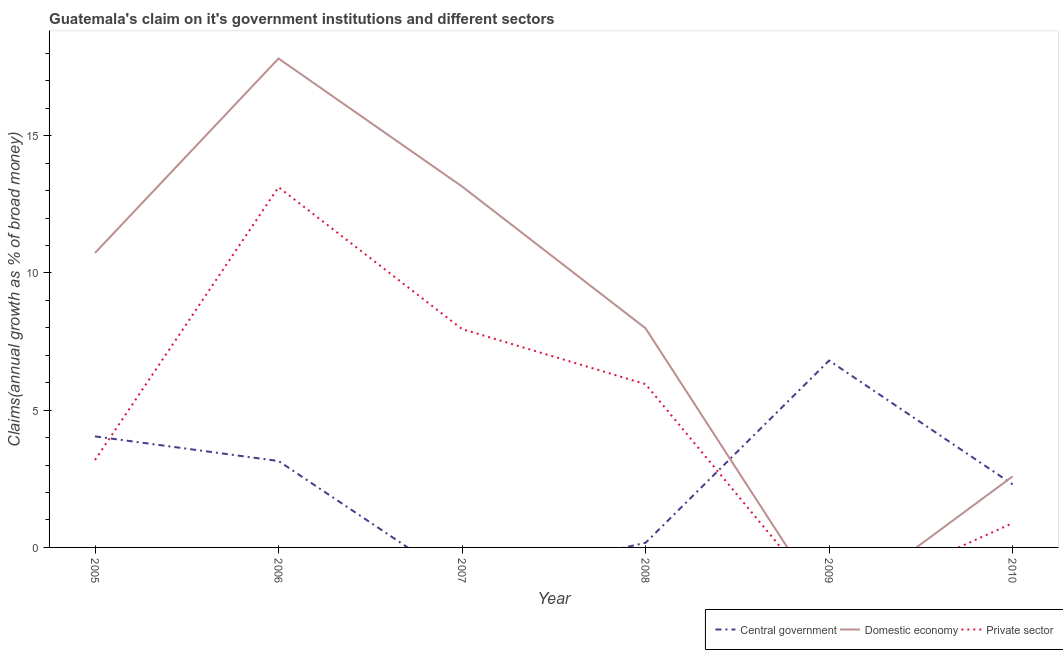How many different coloured lines are there?
Offer a very short reply. 3. Does the line corresponding to percentage of claim on the private sector intersect with the line corresponding to percentage of claim on the domestic economy?
Your response must be concise. Yes. Is the number of lines equal to the number of legend labels?
Your response must be concise. No. What is the percentage of claim on the central government in 2005?
Your response must be concise. 4.05. Across all years, what is the maximum percentage of claim on the domestic economy?
Make the answer very short. 17.81. Across all years, what is the minimum percentage of claim on the domestic economy?
Your response must be concise. 0. In which year was the percentage of claim on the private sector maximum?
Provide a succinct answer. 2006. What is the total percentage of claim on the central government in the graph?
Offer a terse response. 16.47. What is the difference between the percentage of claim on the private sector in 2005 and that in 2007?
Your answer should be very brief. -4.77. What is the difference between the percentage of claim on the central government in 2008 and the percentage of claim on the private sector in 2009?
Your response must be concise. 0.17. What is the average percentage of claim on the central government per year?
Give a very brief answer. 2.75. In the year 2010, what is the difference between the percentage of claim on the private sector and percentage of claim on the central government?
Your response must be concise. -1.41. What is the ratio of the percentage of claim on the private sector in 2005 to that in 2010?
Keep it short and to the point. 3.6. Is the percentage of claim on the private sector in 2005 less than that in 2008?
Make the answer very short. Yes. What is the difference between the highest and the second highest percentage of claim on the central government?
Offer a terse response. 2.76. What is the difference between the highest and the lowest percentage of claim on the central government?
Your response must be concise. 6.81. In how many years, is the percentage of claim on the domestic economy greater than the average percentage of claim on the domestic economy taken over all years?
Ensure brevity in your answer.  3. Does the percentage of claim on the domestic economy monotonically increase over the years?
Make the answer very short. No. Is the percentage of claim on the private sector strictly less than the percentage of claim on the central government over the years?
Make the answer very short. No. What is the difference between two consecutive major ticks on the Y-axis?
Offer a very short reply. 5. Does the graph contain any zero values?
Your answer should be compact. Yes. How many legend labels are there?
Your response must be concise. 3. What is the title of the graph?
Your answer should be very brief. Guatemala's claim on it's government institutions and different sectors. What is the label or title of the Y-axis?
Keep it short and to the point. Claims(annual growth as % of broad money). What is the Claims(annual growth as % of broad money) in Central government in 2005?
Provide a succinct answer. 4.05. What is the Claims(annual growth as % of broad money) in Domestic economy in 2005?
Give a very brief answer. 10.73. What is the Claims(annual growth as % of broad money) in Private sector in 2005?
Your answer should be compact. 3.19. What is the Claims(annual growth as % of broad money) of Central government in 2006?
Give a very brief answer. 3.15. What is the Claims(annual growth as % of broad money) of Domestic economy in 2006?
Provide a succinct answer. 17.81. What is the Claims(annual growth as % of broad money) of Private sector in 2006?
Provide a succinct answer. 13.13. What is the Claims(annual growth as % of broad money) in Domestic economy in 2007?
Provide a short and direct response. 13.15. What is the Claims(annual growth as % of broad money) of Private sector in 2007?
Give a very brief answer. 7.96. What is the Claims(annual growth as % of broad money) of Central government in 2008?
Your answer should be compact. 0.17. What is the Claims(annual growth as % of broad money) in Domestic economy in 2008?
Offer a terse response. 7.98. What is the Claims(annual growth as % of broad money) in Private sector in 2008?
Provide a short and direct response. 5.95. What is the Claims(annual growth as % of broad money) in Central government in 2009?
Give a very brief answer. 6.81. What is the Claims(annual growth as % of broad money) in Private sector in 2009?
Offer a very short reply. 0. What is the Claims(annual growth as % of broad money) in Central government in 2010?
Provide a short and direct response. 2.3. What is the Claims(annual growth as % of broad money) in Domestic economy in 2010?
Your answer should be compact. 2.59. What is the Claims(annual growth as % of broad money) of Private sector in 2010?
Offer a very short reply. 0.88. Across all years, what is the maximum Claims(annual growth as % of broad money) in Central government?
Your answer should be compact. 6.81. Across all years, what is the maximum Claims(annual growth as % of broad money) in Domestic economy?
Make the answer very short. 17.81. Across all years, what is the maximum Claims(annual growth as % of broad money) in Private sector?
Offer a terse response. 13.13. Across all years, what is the minimum Claims(annual growth as % of broad money) in Domestic economy?
Your answer should be compact. 0. Across all years, what is the minimum Claims(annual growth as % of broad money) in Private sector?
Your answer should be very brief. 0. What is the total Claims(annual growth as % of broad money) in Central government in the graph?
Give a very brief answer. 16.47. What is the total Claims(annual growth as % of broad money) of Domestic economy in the graph?
Provide a succinct answer. 52.27. What is the total Claims(annual growth as % of broad money) in Private sector in the graph?
Offer a terse response. 31.1. What is the difference between the Claims(annual growth as % of broad money) in Central government in 2005 and that in 2006?
Your answer should be very brief. 0.9. What is the difference between the Claims(annual growth as % of broad money) of Domestic economy in 2005 and that in 2006?
Keep it short and to the point. -7.08. What is the difference between the Claims(annual growth as % of broad money) in Private sector in 2005 and that in 2006?
Your answer should be very brief. -9.94. What is the difference between the Claims(annual growth as % of broad money) in Domestic economy in 2005 and that in 2007?
Your answer should be very brief. -2.42. What is the difference between the Claims(annual growth as % of broad money) in Private sector in 2005 and that in 2007?
Your response must be concise. -4.77. What is the difference between the Claims(annual growth as % of broad money) in Central government in 2005 and that in 2008?
Make the answer very short. 3.88. What is the difference between the Claims(annual growth as % of broad money) of Domestic economy in 2005 and that in 2008?
Your response must be concise. 2.75. What is the difference between the Claims(annual growth as % of broad money) of Private sector in 2005 and that in 2008?
Give a very brief answer. -2.76. What is the difference between the Claims(annual growth as % of broad money) in Central government in 2005 and that in 2009?
Make the answer very short. -2.76. What is the difference between the Claims(annual growth as % of broad money) of Central government in 2005 and that in 2010?
Your answer should be compact. 1.75. What is the difference between the Claims(annual growth as % of broad money) of Domestic economy in 2005 and that in 2010?
Make the answer very short. 8.14. What is the difference between the Claims(annual growth as % of broad money) in Private sector in 2005 and that in 2010?
Your answer should be very brief. 2.3. What is the difference between the Claims(annual growth as % of broad money) of Domestic economy in 2006 and that in 2007?
Your answer should be compact. 4.66. What is the difference between the Claims(annual growth as % of broad money) in Private sector in 2006 and that in 2007?
Provide a succinct answer. 5.17. What is the difference between the Claims(annual growth as % of broad money) in Central government in 2006 and that in 2008?
Provide a short and direct response. 2.98. What is the difference between the Claims(annual growth as % of broad money) in Domestic economy in 2006 and that in 2008?
Give a very brief answer. 9.83. What is the difference between the Claims(annual growth as % of broad money) of Private sector in 2006 and that in 2008?
Offer a terse response. 7.18. What is the difference between the Claims(annual growth as % of broad money) of Central government in 2006 and that in 2009?
Keep it short and to the point. -3.66. What is the difference between the Claims(annual growth as % of broad money) of Central government in 2006 and that in 2010?
Ensure brevity in your answer.  0.85. What is the difference between the Claims(annual growth as % of broad money) in Domestic economy in 2006 and that in 2010?
Your response must be concise. 15.23. What is the difference between the Claims(annual growth as % of broad money) of Private sector in 2006 and that in 2010?
Provide a succinct answer. 12.24. What is the difference between the Claims(annual growth as % of broad money) in Domestic economy in 2007 and that in 2008?
Keep it short and to the point. 5.17. What is the difference between the Claims(annual growth as % of broad money) of Private sector in 2007 and that in 2008?
Make the answer very short. 2.01. What is the difference between the Claims(annual growth as % of broad money) in Domestic economy in 2007 and that in 2010?
Ensure brevity in your answer.  10.56. What is the difference between the Claims(annual growth as % of broad money) in Private sector in 2007 and that in 2010?
Offer a terse response. 7.07. What is the difference between the Claims(annual growth as % of broad money) in Central government in 2008 and that in 2009?
Your answer should be very brief. -6.64. What is the difference between the Claims(annual growth as % of broad money) of Central government in 2008 and that in 2010?
Offer a very short reply. -2.13. What is the difference between the Claims(annual growth as % of broad money) of Domestic economy in 2008 and that in 2010?
Offer a terse response. 5.39. What is the difference between the Claims(annual growth as % of broad money) of Private sector in 2008 and that in 2010?
Ensure brevity in your answer.  5.06. What is the difference between the Claims(annual growth as % of broad money) of Central government in 2009 and that in 2010?
Make the answer very short. 4.51. What is the difference between the Claims(annual growth as % of broad money) in Central government in 2005 and the Claims(annual growth as % of broad money) in Domestic economy in 2006?
Ensure brevity in your answer.  -13.77. What is the difference between the Claims(annual growth as % of broad money) of Central government in 2005 and the Claims(annual growth as % of broad money) of Private sector in 2006?
Keep it short and to the point. -9.08. What is the difference between the Claims(annual growth as % of broad money) in Domestic economy in 2005 and the Claims(annual growth as % of broad money) in Private sector in 2006?
Offer a very short reply. -2.4. What is the difference between the Claims(annual growth as % of broad money) of Central government in 2005 and the Claims(annual growth as % of broad money) of Domestic economy in 2007?
Provide a succinct answer. -9.11. What is the difference between the Claims(annual growth as % of broad money) of Central government in 2005 and the Claims(annual growth as % of broad money) of Private sector in 2007?
Offer a terse response. -3.91. What is the difference between the Claims(annual growth as % of broad money) in Domestic economy in 2005 and the Claims(annual growth as % of broad money) in Private sector in 2007?
Give a very brief answer. 2.77. What is the difference between the Claims(annual growth as % of broad money) of Central government in 2005 and the Claims(annual growth as % of broad money) of Domestic economy in 2008?
Your answer should be compact. -3.94. What is the difference between the Claims(annual growth as % of broad money) in Central government in 2005 and the Claims(annual growth as % of broad money) in Private sector in 2008?
Ensure brevity in your answer.  -1.9. What is the difference between the Claims(annual growth as % of broad money) in Domestic economy in 2005 and the Claims(annual growth as % of broad money) in Private sector in 2008?
Make the answer very short. 4.78. What is the difference between the Claims(annual growth as % of broad money) in Central government in 2005 and the Claims(annual growth as % of broad money) in Domestic economy in 2010?
Offer a terse response. 1.46. What is the difference between the Claims(annual growth as % of broad money) in Central government in 2005 and the Claims(annual growth as % of broad money) in Private sector in 2010?
Give a very brief answer. 3.16. What is the difference between the Claims(annual growth as % of broad money) in Domestic economy in 2005 and the Claims(annual growth as % of broad money) in Private sector in 2010?
Your answer should be compact. 9.84. What is the difference between the Claims(annual growth as % of broad money) of Central government in 2006 and the Claims(annual growth as % of broad money) of Domestic economy in 2007?
Make the answer very short. -10. What is the difference between the Claims(annual growth as % of broad money) in Central government in 2006 and the Claims(annual growth as % of broad money) in Private sector in 2007?
Your answer should be very brief. -4.81. What is the difference between the Claims(annual growth as % of broad money) in Domestic economy in 2006 and the Claims(annual growth as % of broad money) in Private sector in 2007?
Offer a very short reply. 9.86. What is the difference between the Claims(annual growth as % of broad money) of Central government in 2006 and the Claims(annual growth as % of broad money) of Domestic economy in 2008?
Make the answer very short. -4.83. What is the difference between the Claims(annual growth as % of broad money) of Central government in 2006 and the Claims(annual growth as % of broad money) of Private sector in 2008?
Provide a short and direct response. -2.8. What is the difference between the Claims(annual growth as % of broad money) in Domestic economy in 2006 and the Claims(annual growth as % of broad money) in Private sector in 2008?
Provide a succinct answer. 11.87. What is the difference between the Claims(annual growth as % of broad money) in Central government in 2006 and the Claims(annual growth as % of broad money) in Domestic economy in 2010?
Your answer should be very brief. 0.56. What is the difference between the Claims(annual growth as % of broad money) in Central government in 2006 and the Claims(annual growth as % of broad money) in Private sector in 2010?
Provide a short and direct response. 2.26. What is the difference between the Claims(annual growth as % of broad money) in Domestic economy in 2006 and the Claims(annual growth as % of broad money) in Private sector in 2010?
Your answer should be compact. 16.93. What is the difference between the Claims(annual growth as % of broad money) in Domestic economy in 2007 and the Claims(annual growth as % of broad money) in Private sector in 2008?
Make the answer very short. 7.2. What is the difference between the Claims(annual growth as % of broad money) of Domestic economy in 2007 and the Claims(annual growth as % of broad money) of Private sector in 2010?
Offer a terse response. 12.27. What is the difference between the Claims(annual growth as % of broad money) in Central government in 2008 and the Claims(annual growth as % of broad money) in Domestic economy in 2010?
Offer a very short reply. -2.42. What is the difference between the Claims(annual growth as % of broad money) in Central government in 2008 and the Claims(annual growth as % of broad money) in Private sector in 2010?
Give a very brief answer. -0.72. What is the difference between the Claims(annual growth as % of broad money) in Domestic economy in 2008 and the Claims(annual growth as % of broad money) in Private sector in 2010?
Provide a short and direct response. 7.1. What is the difference between the Claims(annual growth as % of broad money) of Central government in 2009 and the Claims(annual growth as % of broad money) of Domestic economy in 2010?
Your answer should be very brief. 4.22. What is the difference between the Claims(annual growth as % of broad money) in Central government in 2009 and the Claims(annual growth as % of broad money) in Private sector in 2010?
Make the answer very short. 5.92. What is the average Claims(annual growth as % of broad money) in Central government per year?
Your answer should be compact. 2.75. What is the average Claims(annual growth as % of broad money) of Domestic economy per year?
Your answer should be very brief. 8.71. What is the average Claims(annual growth as % of broad money) of Private sector per year?
Provide a short and direct response. 5.18. In the year 2005, what is the difference between the Claims(annual growth as % of broad money) of Central government and Claims(annual growth as % of broad money) of Domestic economy?
Ensure brevity in your answer.  -6.68. In the year 2005, what is the difference between the Claims(annual growth as % of broad money) in Central government and Claims(annual growth as % of broad money) in Private sector?
Give a very brief answer. 0.86. In the year 2005, what is the difference between the Claims(annual growth as % of broad money) in Domestic economy and Claims(annual growth as % of broad money) in Private sector?
Offer a terse response. 7.54. In the year 2006, what is the difference between the Claims(annual growth as % of broad money) of Central government and Claims(annual growth as % of broad money) of Domestic economy?
Keep it short and to the point. -14.67. In the year 2006, what is the difference between the Claims(annual growth as % of broad money) in Central government and Claims(annual growth as % of broad money) in Private sector?
Provide a succinct answer. -9.98. In the year 2006, what is the difference between the Claims(annual growth as % of broad money) of Domestic economy and Claims(annual growth as % of broad money) of Private sector?
Offer a very short reply. 4.69. In the year 2007, what is the difference between the Claims(annual growth as % of broad money) of Domestic economy and Claims(annual growth as % of broad money) of Private sector?
Ensure brevity in your answer.  5.2. In the year 2008, what is the difference between the Claims(annual growth as % of broad money) in Central government and Claims(annual growth as % of broad money) in Domestic economy?
Offer a terse response. -7.81. In the year 2008, what is the difference between the Claims(annual growth as % of broad money) of Central government and Claims(annual growth as % of broad money) of Private sector?
Provide a short and direct response. -5.78. In the year 2008, what is the difference between the Claims(annual growth as % of broad money) of Domestic economy and Claims(annual growth as % of broad money) of Private sector?
Provide a succinct answer. 2.03. In the year 2010, what is the difference between the Claims(annual growth as % of broad money) in Central government and Claims(annual growth as % of broad money) in Domestic economy?
Your answer should be very brief. -0.29. In the year 2010, what is the difference between the Claims(annual growth as % of broad money) of Central government and Claims(annual growth as % of broad money) of Private sector?
Offer a very short reply. 1.41. In the year 2010, what is the difference between the Claims(annual growth as % of broad money) in Domestic economy and Claims(annual growth as % of broad money) in Private sector?
Your answer should be very brief. 1.7. What is the ratio of the Claims(annual growth as % of broad money) in Central government in 2005 to that in 2006?
Provide a short and direct response. 1.28. What is the ratio of the Claims(annual growth as % of broad money) in Domestic economy in 2005 to that in 2006?
Give a very brief answer. 0.6. What is the ratio of the Claims(annual growth as % of broad money) of Private sector in 2005 to that in 2006?
Keep it short and to the point. 0.24. What is the ratio of the Claims(annual growth as % of broad money) of Domestic economy in 2005 to that in 2007?
Your answer should be very brief. 0.82. What is the ratio of the Claims(annual growth as % of broad money) of Private sector in 2005 to that in 2007?
Your response must be concise. 0.4. What is the ratio of the Claims(annual growth as % of broad money) in Central government in 2005 to that in 2008?
Provide a succinct answer. 23.95. What is the ratio of the Claims(annual growth as % of broad money) in Domestic economy in 2005 to that in 2008?
Give a very brief answer. 1.34. What is the ratio of the Claims(annual growth as % of broad money) of Private sector in 2005 to that in 2008?
Offer a terse response. 0.54. What is the ratio of the Claims(annual growth as % of broad money) of Central government in 2005 to that in 2009?
Ensure brevity in your answer.  0.59. What is the ratio of the Claims(annual growth as % of broad money) of Central government in 2005 to that in 2010?
Ensure brevity in your answer.  1.76. What is the ratio of the Claims(annual growth as % of broad money) in Domestic economy in 2005 to that in 2010?
Keep it short and to the point. 4.15. What is the ratio of the Claims(annual growth as % of broad money) of Private sector in 2005 to that in 2010?
Offer a terse response. 3.6. What is the ratio of the Claims(annual growth as % of broad money) of Domestic economy in 2006 to that in 2007?
Offer a terse response. 1.35. What is the ratio of the Claims(annual growth as % of broad money) of Private sector in 2006 to that in 2007?
Offer a very short reply. 1.65. What is the ratio of the Claims(annual growth as % of broad money) in Central government in 2006 to that in 2008?
Your response must be concise. 18.64. What is the ratio of the Claims(annual growth as % of broad money) in Domestic economy in 2006 to that in 2008?
Ensure brevity in your answer.  2.23. What is the ratio of the Claims(annual growth as % of broad money) in Private sector in 2006 to that in 2008?
Your response must be concise. 2.21. What is the ratio of the Claims(annual growth as % of broad money) of Central government in 2006 to that in 2009?
Give a very brief answer. 0.46. What is the ratio of the Claims(annual growth as % of broad money) in Central government in 2006 to that in 2010?
Offer a very short reply. 1.37. What is the ratio of the Claims(annual growth as % of broad money) in Domestic economy in 2006 to that in 2010?
Provide a succinct answer. 6.88. What is the ratio of the Claims(annual growth as % of broad money) of Private sector in 2006 to that in 2010?
Give a very brief answer. 14.84. What is the ratio of the Claims(annual growth as % of broad money) in Domestic economy in 2007 to that in 2008?
Ensure brevity in your answer.  1.65. What is the ratio of the Claims(annual growth as % of broad money) in Private sector in 2007 to that in 2008?
Ensure brevity in your answer.  1.34. What is the ratio of the Claims(annual growth as % of broad money) of Domestic economy in 2007 to that in 2010?
Give a very brief answer. 5.08. What is the ratio of the Claims(annual growth as % of broad money) of Private sector in 2007 to that in 2010?
Ensure brevity in your answer.  8.99. What is the ratio of the Claims(annual growth as % of broad money) of Central government in 2008 to that in 2009?
Your answer should be compact. 0.02. What is the ratio of the Claims(annual growth as % of broad money) of Central government in 2008 to that in 2010?
Give a very brief answer. 0.07. What is the ratio of the Claims(annual growth as % of broad money) of Domestic economy in 2008 to that in 2010?
Give a very brief answer. 3.08. What is the ratio of the Claims(annual growth as % of broad money) in Private sector in 2008 to that in 2010?
Make the answer very short. 6.72. What is the ratio of the Claims(annual growth as % of broad money) in Central government in 2009 to that in 2010?
Provide a short and direct response. 2.96. What is the difference between the highest and the second highest Claims(annual growth as % of broad money) of Central government?
Your response must be concise. 2.76. What is the difference between the highest and the second highest Claims(annual growth as % of broad money) in Domestic economy?
Your answer should be compact. 4.66. What is the difference between the highest and the second highest Claims(annual growth as % of broad money) of Private sector?
Your answer should be very brief. 5.17. What is the difference between the highest and the lowest Claims(annual growth as % of broad money) in Central government?
Ensure brevity in your answer.  6.81. What is the difference between the highest and the lowest Claims(annual growth as % of broad money) in Domestic economy?
Provide a succinct answer. 17.81. What is the difference between the highest and the lowest Claims(annual growth as % of broad money) of Private sector?
Your response must be concise. 13.13. 